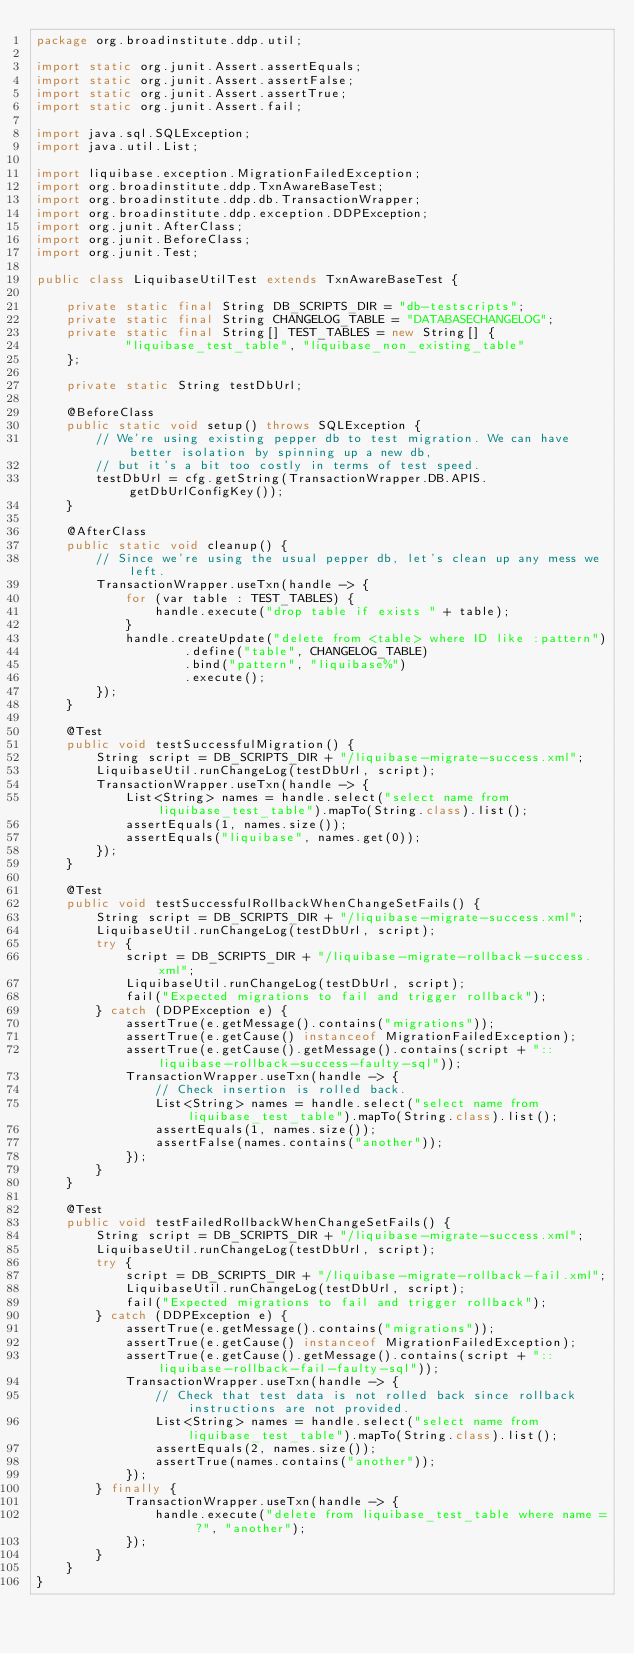<code> <loc_0><loc_0><loc_500><loc_500><_Java_>package org.broadinstitute.ddp.util;

import static org.junit.Assert.assertEquals;
import static org.junit.Assert.assertFalse;
import static org.junit.Assert.assertTrue;
import static org.junit.Assert.fail;

import java.sql.SQLException;
import java.util.List;

import liquibase.exception.MigrationFailedException;
import org.broadinstitute.ddp.TxnAwareBaseTest;
import org.broadinstitute.ddp.db.TransactionWrapper;
import org.broadinstitute.ddp.exception.DDPException;
import org.junit.AfterClass;
import org.junit.BeforeClass;
import org.junit.Test;

public class LiquibaseUtilTest extends TxnAwareBaseTest {

    private static final String DB_SCRIPTS_DIR = "db-testscripts";
    private static final String CHANGELOG_TABLE = "DATABASECHANGELOG";
    private static final String[] TEST_TABLES = new String[] {
            "liquibase_test_table", "liquibase_non_existing_table"
    };

    private static String testDbUrl;

    @BeforeClass
    public static void setup() throws SQLException {
        // We're using existing pepper db to test migration. We can have better isolation by spinning up a new db,
        // but it's a bit too costly in terms of test speed.
        testDbUrl = cfg.getString(TransactionWrapper.DB.APIS.getDbUrlConfigKey());
    }

    @AfterClass
    public static void cleanup() {
        // Since we're using the usual pepper db, let's clean up any mess we left.
        TransactionWrapper.useTxn(handle -> {
            for (var table : TEST_TABLES) {
                handle.execute("drop table if exists " + table);
            }
            handle.createUpdate("delete from <table> where ID like :pattern")
                    .define("table", CHANGELOG_TABLE)
                    .bind("pattern", "liquibase%")
                    .execute();
        });
    }

    @Test
    public void testSuccessfulMigration() {
        String script = DB_SCRIPTS_DIR + "/liquibase-migrate-success.xml";
        LiquibaseUtil.runChangeLog(testDbUrl, script);
        TransactionWrapper.useTxn(handle -> {
            List<String> names = handle.select("select name from liquibase_test_table").mapTo(String.class).list();
            assertEquals(1, names.size());
            assertEquals("liquibase", names.get(0));
        });
    }

    @Test
    public void testSuccessfulRollbackWhenChangeSetFails() {
        String script = DB_SCRIPTS_DIR + "/liquibase-migrate-success.xml";
        LiquibaseUtil.runChangeLog(testDbUrl, script);
        try {
            script = DB_SCRIPTS_DIR + "/liquibase-migrate-rollback-success.xml";
            LiquibaseUtil.runChangeLog(testDbUrl, script);
            fail("Expected migrations to fail and trigger rollback");
        } catch (DDPException e) {
            assertTrue(e.getMessage().contains("migrations"));
            assertTrue(e.getCause() instanceof MigrationFailedException);
            assertTrue(e.getCause().getMessage().contains(script + "::liquibase-rollback-success-faulty-sql"));
            TransactionWrapper.useTxn(handle -> {
                // Check insertion is rolled back.
                List<String> names = handle.select("select name from liquibase_test_table").mapTo(String.class).list();
                assertEquals(1, names.size());
                assertFalse(names.contains("another"));
            });
        }
    }

    @Test
    public void testFailedRollbackWhenChangeSetFails() {
        String script = DB_SCRIPTS_DIR + "/liquibase-migrate-success.xml";
        LiquibaseUtil.runChangeLog(testDbUrl, script);
        try {
            script = DB_SCRIPTS_DIR + "/liquibase-migrate-rollback-fail.xml";
            LiquibaseUtil.runChangeLog(testDbUrl, script);
            fail("Expected migrations to fail and trigger rollback");
        } catch (DDPException e) {
            assertTrue(e.getMessage().contains("migrations"));
            assertTrue(e.getCause() instanceof MigrationFailedException);
            assertTrue(e.getCause().getMessage().contains(script + "::liquibase-rollback-fail-faulty-sql"));
            TransactionWrapper.useTxn(handle -> {
                // Check that test data is not rolled back since rollback instructions are not provided.
                List<String> names = handle.select("select name from liquibase_test_table").mapTo(String.class).list();
                assertEquals(2, names.size());
                assertTrue(names.contains("another"));
            });
        } finally {
            TransactionWrapper.useTxn(handle -> {
                handle.execute("delete from liquibase_test_table where name = ?", "another");
            });
        }
    }
}
</code> 